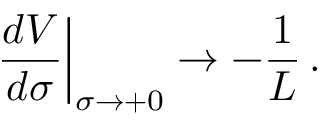Convert formula to latex. <formula><loc_0><loc_0><loc_500><loc_500>\frac { d V } { d \sigma } \right | _ { \sigma \rightarrow + 0 } \rightarrow - \frac { 1 } { L } \, .</formula> 